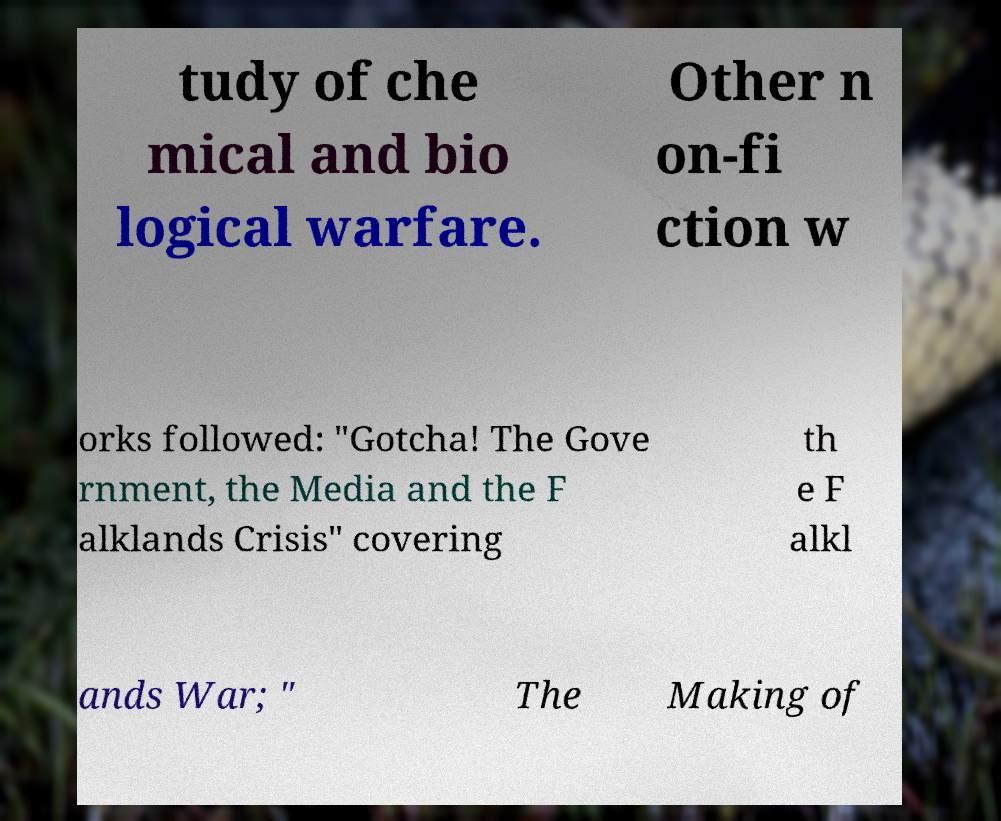I need the written content from this picture converted into text. Can you do that? tudy of che mical and bio logical warfare. Other n on-fi ction w orks followed: "Gotcha! The Gove rnment, the Media and the F alklands Crisis" covering th e F alkl ands War; " The Making of 